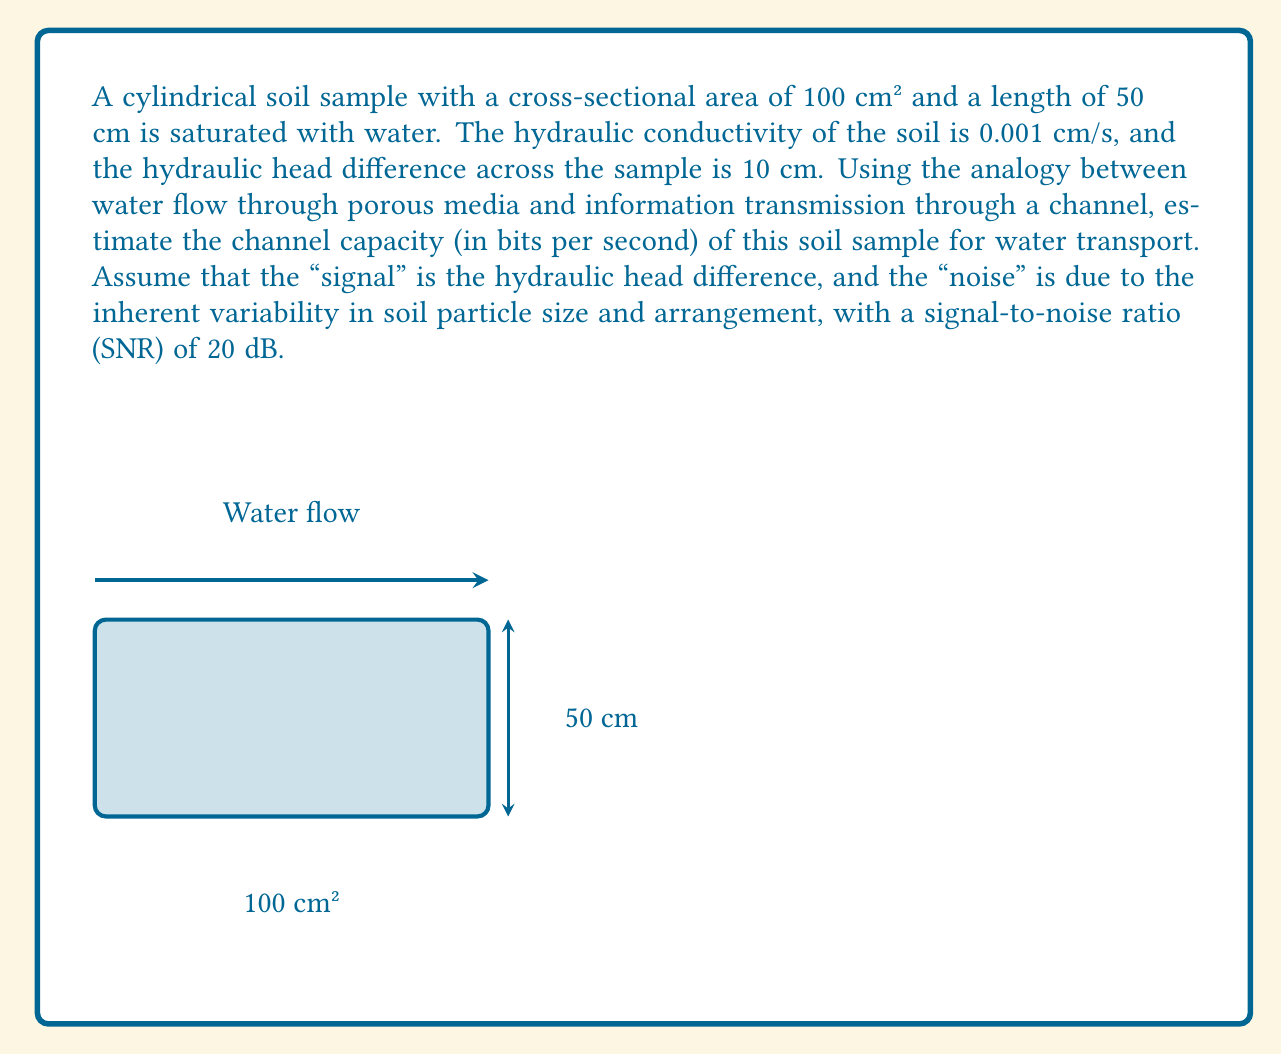Help me with this question. To estimate the channel capacity of the porous medium for water transport, we'll follow these steps:

1) First, calculate the water flow rate using Darcy's law:
   $$Q = K A \frac{\Delta h}{L}$$
   where $Q$ is the flow rate, $K$ is the hydraulic conductivity, $A$ is the cross-sectional area, $\Delta h$ is the hydraulic head difference, and $L$ is the length of the sample.

   $$Q = 0.001 \text{ cm/s} \cdot 100 \text{ cm²} \cdot \frac{10 \text{ cm}}{50 \text{ cm}} = 0.02 \text{ cm³/s}$$

2) Convert the flow rate to bits per second. We can consider each water molecule as carrying information. The number of water molecules in 1 cm³ is approximately $3.34 \times 10^{22}$. So, the number of water molecules per second is:

   $$0.02 \text{ cm³/s} \cdot 3.34 \times 10^{22} \text{ molecules/cm³} = 6.68 \times 10^{20} \text{ molecules/s}$$

3) Now, use the Shannon-Hartley theorem to estimate the channel capacity:
   $$C = B \log_2(1 + \text{SNR})$$
   where $C$ is the channel capacity in bits per second, $B$ is the bandwidth, and SNR is the signal-to-noise ratio.

4) The bandwidth $B$ can be considered as the number of water molecules per second:
   $$B = 6.68 \times 10^{20} \text{ molecules/s}$$

5) Convert the SNR from dB to a linear scale:
   $$\text{SNR}_{\text{linear}} = 10^{\text{SNR}_{\text{dB}}/10} = 10^{20/10} = 100$$

6) Apply the Shannon-Hartley theorem:
   $$C = 6.68 \times 10^{20} \log_2(1 + 100) \approx 4.43 \times 10^{22} \text{ bits/s}$$

Thus, the estimated channel capacity of the soil sample for water transport is approximately $4.43 \times 10^{22}$ bits per second.
Answer: $4.43 \times 10^{22}$ bits/s 